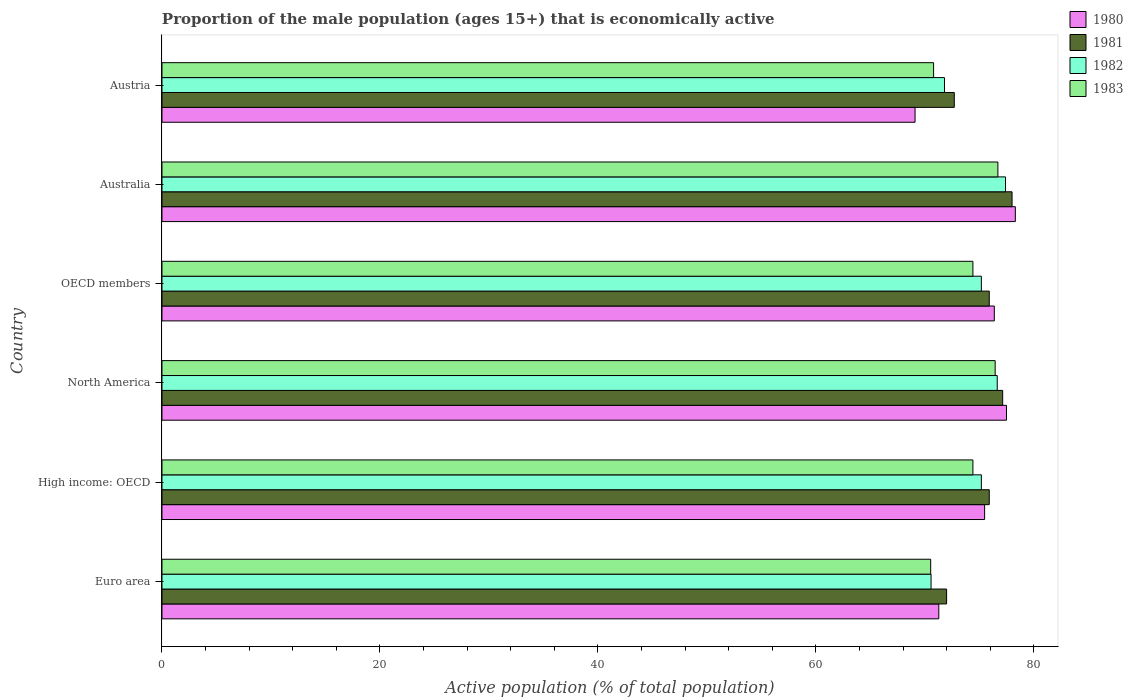How many different coloured bars are there?
Your response must be concise. 4. Are the number of bars per tick equal to the number of legend labels?
Your answer should be compact. Yes. How many bars are there on the 3rd tick from the top?
Your response must be concise. 4. What is the label of the 4th group of bars from the top?
Your answer should be compact. North America. What is the proportion of the male population that is economically active in 1980 in OECD members?
Offer a terse response. 76.37. Across all countries, what is the maximum proportion of the male population that is economically active in 1980?
Your answer should be compact. 78.3. Across all countries, what is the minimum proportion of the male population that is economically active in 1981?
Offer a terse response. 71.99. In which country was the proportion of the male population that is economically active in 1981 maximum?
Your answer should be very brief. Australia. What is the total proportion of the male population that is economically active in 1980 in the graph?
Your answer should be very brief. 448.02. What is the difference between the proportion of the male population that is economically active in 1980 in Australia and that in OECD members?
Provide a short and direct response. 1.93. What is the difference between the proportion of the male population that is economically active in 1981 in Euro area and the proportion of the male population that is economically active in 1980 in High income: OECD?
Your response must be concise. -3.49. What is the average proportion of the male population that is economically active in 1981 per country?
Give a very brief answer. 75.28. What is the difference between the proportion of the male population that is economically active in 1981 and proportion of the male population that is economically active in 1982 in OECD members?
Keep it short and to the point. 0.73. What is the ratio of the proportion of the male population that is economically active in 1982 in Austria to that in OECD members?
Your response must be concise. 0.96. What is the difference between the highest and the second highest proportion of the male population that is economically active in 1980?
Ensure brevity in your answer.  0.81. What is the difference between the highest and the lowest proportion of the male population that is economically active in 1981?
Your response must be concise. 6.01. Is the sum of the proportion of the male population that is economically active in 1983 in Euro area and North America greater than the maximum proportion of the male population that is economically active in 1982 across all countries?
Make the answer very short. Yes. Is it the case that in every country, the sum of the proportion of the male population that is economically active in 1982 and proportion of the male population that is economically active in 1981 is greater than the sum of proportion of the male population that is economically active in 1983 and proportion of the male population that is economically active in 1980?
Give a very brief answer. No. What does the 1st bar from the top in OECD members represents?
Your answer should be compact. 1983. Is it the case that in every country, the sum of the proportion of the male population that is economically active in 1980 and proportion of the male population that is economically active in 1982 is greater than the proportion of the male population that is economically active in 1981?
Provide a short and direct response. Yes. How many bars are there?
Provide a short and direct response. 24. What is the difference between two consecutive major ticks on the X-axis?
Provide a short and direct response. 20. Are the values on the major ticks of X-axis written in scientific E-notation?
Ensure brevity in your answer.  No. Where does the legend appear in the graph?
Your response must be concise. Top right. How many legend labels are there?
Offer a terse response. 4. What is the title of the graph?
Keep it short and to the point. Proportion of the male population (ages 15+) that is economically active. Does "1992" appear as one of the legend labels in the graph?
Provide a succinct answer. No. What is the label or title of the X-axis?
Your answer should be very brief. Active population (% of total population). What is the label or title of the Y-axis?
Your answer should be compact. Country. What is the Active population (% of total population) of 1980 in Euro area?
Make the answer very short. 71.28. What is the Active population (% of total population) in 1981 in Euro area?
Provide a succinct answer. 71.99. What is the Active population (% of total population) in 1982 in Euro area?
Offer a very short reply. 70.57. What is the Active population (% of total population) of 1983 in Euro area?
Give a very brief answer. 70.53. What is the Active population (% of total population) in 1980 in High income: OECD?
Provide a succinct answer. 75.48. What is the Active population (% of total population) in 1981 in High income: OECD?
Your response must be concise. 75.91. What is the Active population (% of total population) in 1982 in High income: OECD?
Make the answer very short. 75.18. What is the Active population (% of total population) of 1983 in High income: OECD?
Your answer should be compact. 74.41. What is the Active population (% of total population) of 1980 in North America?
Offer a terse response. 77.49. What is the Active population (% of total population) in 1981 in North America?
Offer a very short reply. 77.14. What is the Active population (% of total population) of 1982 in North America?
Your response must be concise. 76.64. What is the Active population (% of total population) in 1983 in North America?
Your answer should be very brief. 76.45. What is the Active population (% of total population) in 1980 in OECD members?
Make the answer very short. 76.37. What is the Active population (% of total population) of 1981 in OECD members?
Keep it short and to the point. 75.91. What is the Active population (% of total population) in 1982 in OECD members?
Your answer should be very brief. 75.18. What is the Active population (% of total population) of 1983 in OECD members?
Make the answer very short. 74.41. What is the Active population (% of total population) in 1980 in Australia?
Provide a short and direct response. 78.3. What is the Active population (% of total population) in 1981 in Australia?
Offer a terse response. 78. What is the Active population (% of total population) of 1982 in Australia?
Provide a succinct answer. 77.4. What is the Active population (% of total population) in 1983 in Australia?
Offer a terse response. 76.7. What is the Active population (% of total population) in 1980 in Austria?
Provide a succinct answer. 69.1. What is the Active population (% of total population) of 1981 in Austria?
Your response must be concise. 72.7. What is the Active population (% of total population) of 1982 in Austria?
Offer a terse response. 71.8. What is the Active population (% of total population) of 1983 in Austria?
Ensure brevity in your answer.  70.8. Across all countries, what is the maximum Active population (% of total population) of 1980?
Offer a terse response. 78.3. Across all countries, what is the maximum Active population (% of total population) in 1981?
Provide a short and direct response. 78. Across all countries, what is the maximum Active population (% of total population) in 1982?
Keep it short and to the point. 77.4. Across all countries, what is the maximum Active population (% of total population) of 1983?
Offer a very short reply. 76.7. Across all countries, what is the minimum Active population (% of total population) in 1980?
Keep it short and to the point. 69.1. Across all countries, what is the minimum Active population (% of total population) of 1981?
Your answer should be very brief. 71.99. Across all countries, what is the minimum Active population (% of total population) in 1982?
Provide a succinct answer. 70.57. Across all countries, what is the minimum Active population (% of total population) of 1983?
Provide a short and direct response. 70.53. What is the total Active population (% of total population) of 1980 in the graph?
Your answer should be compact. 448.02. What is the total Active population (% of total population) in 1981 in the graph?
Keep it short and to the point. 451.65. What is the total Active population (% of total population) of 1982 in the graph?
Provide a short and direct response. 446.77. What is the total Active population (% of total population) of 1983 in the graph?
Offer a very short reply. 443.3. What is the difference between the Active population (% of total population) in 1980 in Euro area and that in High income: OECD?
Your response must be concise. -4.2. What is the difference between the Active population (% of total population) of 1981 in Euro area and that in High income: OECD?
Ensure brevity in your answer.  -3.92. What is the difference between the Active population (% of total population) in 1982 in Euro area and that in High income: OECD?
Provide a short and direct response. -4.61. What is the difference between the Active population (% of total population) of 1983 in Euro area and that in High income: OECD?
Provide a succinct answer. -3.87. What is the difference between the Active population (% of total population) in 1980 in Euro area and that in North America?
Ensure brevity in your answer.  -6.21. What is the difference between the Active population (% of total population) of 1981 in Euro area and that in North America?
Give a very brief answer. -5.15. What is the difference between the Active population (% of total population) in 1982 in Euro area and that in North America?
Provide a short and direct response. -6.07. What is the difference between the Active population (% of total population) in 1983 in Euro area and that in North America?
Provide a succinct answer. -5.92. What is the difference between the Active population (% of total population) in 1980 in Euro area and that in OECD members?
Your answer should be very brief. -5.09. What is the difference between the Active population (% of total population) in 1981 in Euro area and that in OECD members?
Your answer should be very brief. -3.92. What is the difference between the Active population (% of total population) of 1982 in Euro area and that in OECD members?
Your response must be concise. -4.61. What is the difference between the Active population (% of total population) in 1983 in Euro area and that in OECD members?
Provide a short and direct response. -3.87. What is the difference between the Active population (% of total population) in 1980 in Euro area and that in Australia?
Provide a short and direct response. -7.02. What is the difference between the Active population (% of total population) in 1981 in Euro area and that in Australia?
Your answer should be compact. -6.01. What is the difference between the Active population (% of total population) of 1982 in Euro area and that in Australia?
Offer a very short reply. -6.83. What is the difference between the Active population (% of total population) in 1983 in Euro area and that in Australia?
Your answer should be compact. -6.17. What is the difference between the Active population (% of total population) in 1980 in Euro area and that in Austria?
Offer a terse response. 2.18. What is the difference between the Active population (% of total population) in 1981 in Euro area and that in Austria?
Offer a terse response. -0.71. What is the difference between the Active population (% of total population) of 1982 in Euro area and that in Austria?
Your answer should be very brief. -1.23. What is the difference between the Active population (% of total population) in 1983 in Euro area and that in Austria?
Provide a succinct answer. -0.27. What is the difference between the Active population (% of total population) of 1980 in High income: OECD and that in North America?
Give a very brief answer. -2.01. What is the difference between the Active population (% of total population) in 1981 in High income: OECD and that in North America?
Offer a very short reply. -1.23. What is the difference between the Active population (% of total population) of 1982 in High income: OECD and that in North America?
Offer a terse response. -1.46. What is the difference between the Active population (% of total population) in 1983 in High income: OECD and that in North America?
Keep it short and to the point. -2.04. What is the difference between the Active population (% of total population) in 1980 in High income: OECD and that in OECD members?
Offer a very short reply. -0.89. What is the difference between the Active population (% of total population) of 1980 in High income: OECD and that in Australia?
Provide a succinct answer. -2.82. What is the difference between the Active population (% of total population) in 1981 in High income: OECD and that in Australia?
Offer a very short reply. -2.09. What is the difference between the Active population (% of total population) in 1982 in High income: OECD and that in Australia?
Your response must be concise. -2.22. What is the difference between the Active population (% of total population) of 1983 in High income: OECD and that in Australia?
Your answer should be compact. -2.29. What is the difference between the Active population (% of total population) of 1980 in High income: OECD and that in Austria?
Provide a succinct answer. 6.38. What is the difference between the Active population (% of total population) in 1981 in High income: OECD and that in Austria?
Your answer should be compact. 3.21. What is the difference between the Active population (% of total population) in 1982 in High income: OECD and that in Austria?
Your response must be concise. 3.38. What is the difference between the Active population (% of total population) in 1983 in High income: OECD and that in Austria?
Ensure brevity in your answer.  3.61. What is the difference between the Active population (% of total population) of 1980 in North America and that in OECD members?
Your response must be concise. 1.12. What is the difference between the Active population (% of total population) in 1981 in North America and that in OECD members?
Provide a short and direct response. 1.23. What is the difference between the Active population (% of total population) of 1982 in North America and that in OECD members?
Ensure brevity in your answer.  1.46. What is the difference between the Active population (% of total population) in 1983 in North America and that in OECD members?
Your answer should be very brief. 2.04. What is the difference between the Active population (% of total population) of 1980 in North America and that in Australia?
Offer a terse response. -0.81. What is the difference between the Active population (% of total population) in 1981 in North America and that in Australia?
Your answer should be compact. -0.86. What is the difference between the Active population (% of total population) of 1982 in North America and that in Australia?
Keep it short and to the point. -0.76. What is the difference between the Active population (% of total population) in 1983 in North America and that in Australia?
Your answer should be very brief. -0.25. What is the difference between the Active population (% of total population) in 1980 in North America and that in Austria?
Give a very brief answer. 8.39. What is the difference between the Active population (% of total population) of 1981 in North America and that in Austria?
Your answer should be very brief. 4.44. What is the difference between the Active population (% of total population) of 1982 in North America and that in Austria?
Ensure brevity in your answer.  4.84. What is the difference between the Active population (% of total population) in 1983 in North America and that in Austria?
Provide a succinct answer. 5.65. What is the difference between the Active population (% of total population) of 1980 in OECD members and that in Australia?
Make the answer very short. -1.93. What is the difference between the Active population (% of total population) of 1981 in OECD members and that in Australia?
Your answer should be compact. -2.09. What is the difference between the Active population (% of total population) of 1982 in OECD members and that in Australia?
Ensure brevity in your answer.  -2.22. What is the difference between the Active population (% of total population) of 1983 in OECD members and that in Australia?
Offer a very short reply. -2.29. What is the difference between the Active population (% of total population) of 1980 in OECD members and that in Austria?
Your answer should be compact. 7.27. What is the difference between the Active population (% of total population) of 1981 in OECD members and that in Austria?
Your answer should be compact. 3.21. What is the difference between the Active population (% of total population) in 1982 in OECD members and that in Austria?
Your answer should be very brief. 3.38. What is the difference between the Active population (% of total population) of 1983 in OECD members and that in Austria?
Your answer should be compact. 3.61. What is the difference between the Active population (% of total population) of 1980 in Australia and that in Austria?
Offer a very short reply. 9.2. What is the difference between the Active population (% of total population) in 1981 in Australia and that in Austria?
Your answer should be very brief. 5.3. What is the difference between the Active population (% of total population) of 1982 in Australia and that in Austria?
Offer a very short reply. 5.6. What is the difference between the Active population (% of total population) of 1983 in Australia and that in Austria?
Provide a succinct answer. 5.9. What is the difference between the Active population (% of total population) of 1980 in Euro area and the Active population (% of total population) of 1981 in High income: OECD?
Provide a short and direct response. -4.63. What is the difference between the Active population (% of total population) of 1980 in Euro area and the Active population (% of total population) of 1982 in High income: OECD?
Your answer should be very brief. -3.9. What is the difference between the Active population (% of total population) of 1980 in Euro area and the Active population (% of total population) of 1983 in High income: OECD?
Offer a terse response. -3.13. What is the difference between the Active population (% of total population) in 1981 in Euro area and the Active population (% of total population) in 1982 in High income: OECD?
Provide a succinct answer. -3.19. What is the difference between the Active population (% of total population) in 1981 in Euro area and the Active population (% of total population) in 1983 in High income: OECD?
Provide a succinct answer. -2.41. What is the difference between the Active population (% of total population) in 1982 in Euro area and the Active population (% of total population) in 1983 in High income: OECD?
Your answer should be very brief. -3.84. What is the difference between the Active population (% of total population) of 1980 in Euro area and the Active population (% of total population) of 1981 in North America?
Your answer should be compact. -5.86. What is the difference between the Active population (% of total population) in 1980 in Euro area and the Active population (% of total population) in 1982 in North America?
Provide a short and direct response. -5.36. What is the difference between the Active population (% of total population) in 1980 in Euro area and the Active population (% of total population) in 1983 in North America?
Make the answer very short. -5.17. What is the difference between the Active population (% of total population) in 1981 in Euro area and the Active population (% of total population) in 1982 in North America?
Make the answer very short. -4.65. What is the difference between the Active population (% of total population) in 1981 in Euro area and the Active population (% of total population) in 1983 in North America?
Make the answer very short. -4.46. What is the difference between the Active population (% of total population) in 1982 in Euro area and the Active population (% of total population) in 1983 in North America?
Your answer should be very brief. -5.88. What is the difference between the Active population (% of total population) in 1980 in Euro area and the Active population (% of total population) in 1981 in OECD members?
Make the answer very short. -4.63. What is the difference between the Active population (% of total population) of 1980 in Euro area and the Active population (% of total population) of 1982 in OECD members?
Make the answer very short. -3.9. What is the difference between the Active population (% of total population) of 1980 in Euro area and the Active population (% of total population) of 1983 in OECD members?
Offer a terse response. -3.13. What is the difference between the Active population (% of total population) in 1981 in Euro area and the Active population (% of total population) in 1982 in OECD members?
Your answer should be compact. -3.19. What is the difference between the Active population (% of total population) in 1981 in Euro area and the Active population (% of total population) in 1983 in OECD members?
Offer a terse response. -2.41. What is the difference between the Active population (% of total population) in 1982 in Euro area and the Active population (% of total population) in 1983 in OECD members?
Give a very brief answer. -3.84. What is the difference between the Active population (% of total population) of 1980 in Euro area and the Active population (% of total population) of 1981 in Australia?
Keep it short and to the point. -6.72. What is the difference between the Active population (% of total population) of 1980 in Euro area and the Active population (% of total population) of 1982 in Australia?
Provide a short and direct response. -6.12. What is the difference between the Active population (% of total population) of 1980 in Euro area and the Active population (% of total population) of 1983 in Australia?
Make the answer very short. -5.42. What is the difference between the Active population (% of total population) of 1981 in Euro area and the Active population (% of total population) of 1982 in Australia?
Provide a succinct answer. -5.41. What is the difference between the Active population (% of total population) in 1981 in Euro area and the Active population (% of total population) in 1983 in Australia?
Your response must be concise. -4.71. What is the difference between the Active population (% of total population) in 1982 in Euro area and the Active population (% of total population) in 1983 in Australia?
Provide a succinct answer. -6.13. What is the difference between the Active population (% of total population) in 1980 in Euro area and the Active population (% of total population) in 1981 in Austria?
Ensure brevity in your answer.  -1.42. What is the difference between the Active population (% of total population) in 1980 in Euro area and the Active population (% of total population) in 1982 in Austria?
Provide a succinct answer. -0.52. What is the difference between the Active population (% of total population) of 1980 in Euro area and the Active population (% of total population) of 1983 in Austria?
Provide a succinct answer. 0.48. What is the difference between the Active population (% of total population) of 1981 in Euro area and the Active population (% of total population) of 1982 in Austria?
Keep it short and to the point. 0.19. What is the difference between the Active population (% of total population) in 1981 in Euro area and the Active population (% of total population) in 1983 in Austria?
Your answer should be compact. 1.19. What is the difference between the Active population (% of total population) of 1982 in Euro area and the Active population (% of total population) of 1983 in Austria?
Offer a very short reply. -0.23. What is the difference between the Active population (% of total population) in 1980 in High income: OECD and the Active population (% of total population) in 1981 in North America?
Keep it short and to the point. -1.66. What is the difference between the Active population (% of total population) in 1980 in High income: OECD and the Active population (% of total population) in 1982 in North America?
Keep it short and to the point. -1.16. What is the difference between the Active population (% of total population) of 1980 in High income: OECD and the Active population (% of total population) of 1983 in North America?
Give a very brief answer. -0.97. What is the difference between the Active population (% of total population) of 1981 in High income: OECD and the Active population (% of total population) of 1982 in North America?
Offer a terse response. -0.73. What is the difference between the Active population (% of total population) of 1981 in High income: OECD and the Active population (% of total population) of 1983 in North America?
Provide a succinct answer. -0.54. What is the difference between the Active population (% of total population) of 1982 in High income: OECD and the Active population (% of total population) of 1983 in North America?
Offer a very short reply. -1.27. What is the difference between the Active population (% of total population) in 1980 in High income: OECD and the Active population (% of total population) in 1981 in OECD members?
Keep it short and to the point. -0.43. What is the difference between the Active population (% of total population) of 1980 in High income: OECD and the Active population (% of total population) of 1982 in OECD members?
Your answer should be very brief. 0.3. What is the difference between the Active population (% of total population) in 1980 in High income: OECD and the Active population (% of total population) in 1983 in OECD members?
Your answer should be compact. 1.07. What is the difference between the Active population (% of total population) of 1981 in High income: OECD and the Active population (% of total population) of 1982 in OECD members?
Provide a succinct answer. 0.73. What is the difference between the Active population (% of total population) of 1981 in High income: OECD and the Active population (% of total population) of 1983 in OECD members?
Offer a terse response. 1.5. What is the difference between the Active population (% of total population) in 1982 in High income: OECD and the Active population (% of total population) in 1983 in OECD members?
Your answer should be very brief. 0.77. What is the difference between the Active population (% of total population) in 1980 in High income: OECD and the Active population (% of total population) in 1981 in Australia?
Your answer should be very brief. -2.52. What is the difference between the Active population (% of total population) in 1980 in High income: OECD and the Active population (% of total population) in 1982 in Australia?
Offer a terse response. -1.92. What is the difference between the Active population (% of total population) in 1980 in High income: OECD and the Active population (% of total population) in 1983 in Australia?
Provide a succinct answer. -1.22. What is the difference between the Active population (% of total population) in 1981 in High income: OECD and the Active population (% of total population) in 1982 in Australia?
Make the answer very short. -1.49. What is the difference between the Active population (% of total population) of 1981 in High income: OECD and the Active population (% of total population) of 1983 in Australia?
Give a very brief answer. -0.79. What is the difference between the Active population (% of total population) in 1982 in High income: OECD and the Active population (% of total population) in 1983 in Australia?
Offer a very short reply. -1.52. What is the difference between the Active population (% of total population) in 1980 in High income: OECD and the Active population (% of total population) in 1981 in Austria?
Offer a terse response. 2.78. What is the difference between the Active population (% of total population) of 1980 in High income: OECD and the Active population (% of total population) of 1982 in Austria?
Offer a very short reply. 3.68. What is the difference between the Active population (% of total population) in 1980 in High income: OECD and the Active population (% of total population) in 1983 in Austria?
Ensure brevity in your answer.  4.68. What is the difference between the Active population (% of total population) in 1981 in High income: OECD and the Active population (% of total population) in 1982 in Austria?
Keep it short and to the point. 4.11. What is the difference between the Active population (% of total population) in 1981 in High income: OECD and the Active population (% of total population) in 1983 in Austria?
Give a very brief answer. 5.11. What is the difference between the Active population (% of total population) in 1982 in High income: OECD and the Active population (% of total population) in 1983 in Austria?
Offer a terse response. 4.38. What is the difference between the Active population (% of total population) of 1980 in North America and the Active population (% of total population) of 1981 in OECD members?
Provide a short and direct response. 1.58. What is the difference between the Active population (% of total population) of 1980 in North America and the Active population (% of total population) of 1982 in OECD members?
Your answer should be very brief. 2.31. What is the difference between the Active population (% of total population) in 1980 in North America and the Active population (% of total population) in 1983 in OECD members?
Provide a succinct answer. 3.08. What is the difference between the Active population (% of total population) of 1981 in North America and the Active population (% of total population) of 1982 in OECD members?
Your answer should be very brief. 1.96. What is the difference between the Active population (% of total population) in 1981 in North America and the Active population (% of total population) in 1983 in OECD members?
Your answer should be compact. 2.73. What is the difference between the Active population (% of total population) of 1982 in North America and the Active population (% of total population) of 1983 in OECD members?
Provide a short and direct response. 2.23. What is the difference between the Active population (% of total population) of 1980 in North America and the Active population (% of total population) of 1981 in Australia?
Offer a very short reply. -0.51. What is the difference between the Active population (% of total population) of 1980 in North America and the Active population (% of total population) of 1982 in Australia?
Offer a terse response. 0.09. What is the difference between the Active population (% of total population) in 1980 in North America and the Active population (% of total population) in 1983 in Australia?
Keep it short and to the point. 0.79. What is the difference between the Active population (% of total population) of 1981 in North America and the Active population (% of total population) of 1982 in Australia?
Make the answer very short. -0.26. What is the difference between the Active population (% of total population) of 1981 in North America and the Active population (% of total population) of 1983 in Australia?
Your answer should be very brief. 0.44. What is the difference between the Active population (% of total population) in 1982 in North America and the Active population (% of total population) in 1983 in Australia?
Make the answer very short. -0.06. What is the difference between the Active population (% of total population) of 1980 in North America and the Active population (% of total population) of 1981 in Austria?
Provide a succinct answer. 4.79. What is the difference between the Active population (% of total population) of 1980 in North America and the Active population (% of total population) of 1982 in Austria?
Your answer should be compact. 5.69. What is the difference between the Active population (% of total population) in 1980 in North America and the Active population (% of total population) in 1983 in Austria?
Provide a short and direct response. 6.69. What is the difference between the Active population (% of total population) in 1981 in North America and the Active population (% of total population) in 1982 in Austria?
Your response must be concise. 5.34. What is the difference between the Active population (% of total population) of 1981 in North America and the Active population (% of total population) of 1983 in Austria?
Keep it short and to the point. 6.34. What is the difference between the Active population (% of total population) of 1982 in North America and the Active population (% of total population) of 1983 in Austria?
Provide a succinct answer. 5.84. What is the difference between the Active population (% of total population) of 1980 in OECD members and the Active population (% of total population) of 1981 in Australia?
Provide a short and direct response. -1.63. What is the difference between the Active population (% of total population) in 1980 in OECD members and the Active population (% of total population) in 1982 in Australia?
Your response must be concise. -1.03. What is the difference between the Active population (% of total population) of 1980 in OECD members and the Active population (% of total population) of 1983 in Australia?
Ensure brevity in your answer.  -0.33. What is the difference between the Active population (% of total population) in 1981 in OECD members and the Active population (% of total population) in 1982 in Australia?
Keep it short and to the point. -1.49. What is the difference between the Active population (% of total population) in 1981 in OECD members and the Active population (% of total population) in 1983 in Australia?
Provide a short and direct response. -0.79. What is the difference between the Active population (% of total population) in 1982 in OECD members and the Active population (% of total population) in 1983 in Australia?
Ensure brevity in your answer.  -1.52. What is the difference between the Active population (% of total population) in 1980 in OECD members and the Active population (% of total population) in 1981 in Austria?
Provide a short and direct response. 3.67. What is the difference between the Active population (% of total population) of 1980 in OECD members and the Active population (% of total population) of 1982 in Austria?
Offer a terse response. 4.57. What is the difference between the Active population (% of total population) in 1980 in OECD members and the Active population (% of total population) in 1983 in Austria?
Your answer should be compact. 5.57. What is the difference between the Active population (% of total population) in 1981 in OECD members and the Active population (% of total population) in 1982 in Austria?
Keep it short and to the point. 4.11. What is the difference between the Active population (% of total population) in 1981 in OECD members and the Active population (% of total population) in 1983 in Austria?
Make the answer very short. 5.11. What is the difference between the Active population (% of total population) of 1982 in OECD members and the Active population (% of total population) of 1983 in Austria?
Give a very brief answer. 4.38. What is the difference between the Active population (% of total population) in 1980 in Australia and the Active population (% of total population) in 1982 in Austria?
Ensure brevity in your answer.  6.5. What is the difference between the Active population (% of total population) of 1980 in Australia and the Active population (% of total population) of 1983 in Austria?
Provide a succinct answer. 7.5. What is the difference between the Active population (% of total population) in 1981 in Australia and the Active population (% of total population) in 1982 in Austria?
Provide a short and direct response. 6.2. What is the difference between the Active population (% of total population) in 1981 in Australia and the Active population (% of total population) in 1983 in Austria?
Your response must be concise. 7.2. What is the average Active population (% of total population) of 1980 per country?
Ensure brevity in your answer.  74.67. What is the average Active population (% of total population) of 1981 per country?
Provide a succinct answer. 75.28. What is the average Active population (% of total population) of 1982 per country?
Give a very brief answer. 74.46. What is the average Active population (% of total population) of 1983 per country?
Your answer should be very brief. 73.88. What is the difference between the Active population (% of total population) of 1980 and Active population (% of total population) of 1981 in Euro area?
Keep it short and to the point. -0.72. What is the difference between the Active population (% of total population) of 1980 and Active population (% of total population) of 1982 in Euro area?
Keep it short and to the point. 0.71. What is the difference between the Active population (% of total population) in 1980 and Active population (% of total population) in 1983 in Euro area?
Make the answer very short. 0.74. What is the difference between the Active population (% of total population) of 1981 and Active population (% of total population) of 1982 in Euro area?
Provide a short and direct response. 1.43. What is the difference between the Active population (% of total population) of 1981 and Active population (% of total population) of 1983 in Euro area?
Keep it short and to the point. 1.46. What is the difference between the Active population (% of total population) in 1982 and Active population (% of total population) in 1983 in Euro area?
Offer a very short reply. 0.03. What is the difference between the Active population (% of total population) in 1980 and Active population (% of total population) in 1981 in High income: OECD?
Give a very brief answer. -0.43. What is the difference between the Active population (% of total population) in 1980 and Active population (% of total population) in 1982 in High income: OECD?
Make the answer very short. 0.3. What is the difference between the Active population (% of total population) of 1980 and Active population (% of total population) of 1983 in High income: OECD?
Offer a very short reply. 1.07. What is the difference between the Active population (% of total population) of 1981 and Active population (% of total population) of 1982 in High income: OECD?
Offer a terse response. 0.73. What is the difference between the Active population (% of total population) in 1981 and Active population (% of total population) in 1983 in High income: OECD?
Give a very brief answer. 1.5. What is the difference between the Active population (% of total population) of 1982 and Active population (% of total population) of 1983 in High income: OECD?
Give a very brief answer. 0.77. What is the difference between the Active population (% of total population) of 1980 and Active population (% of total population) of 1981 in North America?
Offer a very short reply. 0.35. What is the difference between the Active population (% of total population) of 1980 and Active population (% of total population) of 1982 in North America?
Make the answer very short. 0.85. What is the difference between the Active population (% of total population) in 1980 and Active population (% of total population) in 1983 in North America?
Offer a very short reply. 1.04. What is the difference between the Active population (% of total population) in 1981 and Active population (% of total population) in 1982 in North America?
Offer a very short reply. 0.5. What is the difference between the Active population (% of total population) in 1981 and Active population (% of total population) in 1983 in North America?
Provide a short and direct response. 0.69. What is the difference between the Active population (% of total population) of 1982 and Active population (% of total population) of 1983 in North America?
Your answer should be compact. 0.19. What is the difference between the Active population (% of total population) of 1980 and Active population (% of total population) of 1981 in OECD members?
Your answer should be compact. 0.46. What is the difference between the Active population (% of total population) of 1980 and Active population (% of total population) of 1982 in OECD members?
Keep it short and to the point. 1.19. What is the difference between the Active population (% of total population) in 1980 and Active population (% of total population) in 1983 in OECD members?
Make the answer very short. 1.96. What is the difference between the Active population (% of total population) of 1981 and Active population (% of total population) of 1982 in OECD members?
Ensure brevity in your answer.  0.73. What is the difference between the Active population (% of total population) in 1981 and Active population (% of total population) in 1983 in OECD members?
Give a very brief answer. 1.5. What is the difference between the Active population (% of total population) in 1982 and Active population (% of total population) in 1983 in OECD members?
Your answer should be very brief. 0.77. What is the difference between the Active population (% of total population) in 1980 and Active population (% of total population) in 1981 in Australia?
Your answer should be compact. 0.3. What is the difference between the Active population (% of total population) of 1980 and Active population (% of total population) of 1982 in Australia?
Keep it short and to the point. 0.9. What is the difference between the Active population (% of total population) in 1980 and Active population (% of total population) in 1983 in Australia?
Your answer should be compact. 1.6. What is the difference between the Active population (% of total population) in 1981 and Active population (% of total population) in 1983 in Australia?
Make the answer very short. 1.3. What is the difference between the Active population (% of total population) in 1982 and Active population (% of total population) in 1983 in Australia?
Your response must be concise. 0.7. What is the difference between the Active population (% of total population) in 1980 and Active population (% of total population) in 1983 in Austria?
Ensure brevity in your answer.  -1.7. What is the difference between the Active population (% of total population) in 1982 and Active population (% of total population) in 1983 in Austria?
Your answer should be compact. 1. What is the ratio of the Active population (% of total population) in 1980 in Euro area to that in High income: OECD?
Give a very brief answer. 0.94. What is the ratio of the Active population (% of total population) in 1981 in Euro area to that in High income: OECD?
Ensure brevity in your answer.  0.95. What is the ratio of the Active population (% of total population) of 1982 in Euro area to that in High income: OECD?
Ensure brevity in your answer.  0.94. What is the ratio of the Active population (% of total population) in 1983 in Euro area to that in High income: OECD?
Make the answer very short. 0.95. What is the ratio of the Active population (% of total population) in 1980 in Euro area to that in North America?
Provide a succinct answer. 0.92. What is the ratio of the Active population (% of total population) of 1982 in Euro area to that in North America?
Make the answer very short. 0.92. What is the ratio of the Active population (% of total population) in 1983 in Euro area to that in North America?
Provide a short and direct response. 0.92. What is the ratio of the Active population (% of total population) in 1981 in Euro area to that in OECD members?
Your answer should be very brief. 0.95. What is the ratio of the Active population (% of total population) of 1982 in Euro area to that in OECD members?
Make the answer very short. 0.94. What is the ratio of the Active population (% of total population) in 1983 in Euro area to that in OECD members?
Give a very brief answer. 0.95. What is the ratio of the Active population (% of total population) in 1980 in Euro area to that in Australia?
Offer a terse response. 0.91. What is the ratio of the Active population (% of total population) in 1981 in Euro area to that in Australia?
Give a very brief answer. 0.92. What is the ratio of the Active population (% of total population) of 1982 in Euro area to that in Australia?
Offer a terse response. 0.91. What is the ratio of the Active population (% of total population) in 1983 in Euro area to that in Australia?
Make the answer very short. 0.92. What is the ratio of the Active population (% of total population) in 1980 in Euro area to that in Austria?
Keep it short and to the point. 1.03. What is the ratio of the Active population (% of total population) of 1981 in Euro area to that in Austria?
Make the answer very short. 0.99. What is the ratio of the Active population (% of total population) in 1982 in Euro area to that in Austria?
Your answer should be very brief. 0.98. What is the ratio of the Active population (% of total population) in 1983 in Euro area to that in Austria?
Provide a short and direct response. 1. What is the ratio of the Active population (% of total population) in 1980 in High income: OECD to that in North America?
Provide a succinct answer. 0.97. What is the ratio of the Active population (% of total population) in 1983 in High income: OECD to that in North America?
Keep it short and to the point. 0.97. What is the ratio of the Active population (% of total population) in 1980 in High income: OECD to that in OECD members?
Ensure brevity in your answer.  0.99. What is the ratio of the Active population (% of total population) of 1981 in High income: OECD to that in OECD members?
Your response must be concise. 1. What is the ratio of the Active population (% of total population) of 1983 in High income: OECD to that in OECD members?
Offer a very short reply. 1. What is the ratio of the Active population (% of total population) of 1981 in High income: OECD to that in Australia?
Ensure brevity in your answer.  0.97. What is the ratio of the Active population (% of total population) of 1982 in High income: OECD to that in Australia?
Offer a very short reply. 0.97. What is the ratio of the Active population (% of total population) of 1983 in High income: OECD to that in Australia?
Offer a very short reply. 0.97. What is the ratio of the Active population (% of total population) in 1980 in High income: OECD to that in Austria?
Your response must be concise. 1.09. What is the ratio of the Active population (% of total population) in 1981 in High income: OECD to that in Austria?
Offer a very short reply. 1.04. What is the ratio of the Active population (% of total population) of 1982 in High income: OECD to that in Austria?
Keep it short and to the point. 1.05. What is the ratio of the Active population (% of total population) in 1983 in High income: OECD to that in Austria?
Ensure brevity in your answer.  1.05. What is the ratio of the Active population (% of total population) in 1980 in North America to that in OECD members?
Ensure brevity in your answer.  1.01. What is the ratio of the Active population (% of total population) of 1981 in North America to that in OECD members?
Your response must be concise. 1.02. What is the ratio of the Active population (% of total population) of 1982 in North America to that in OECD members?
Ensure brevity in your answer.  1.02. What is the ratio of the Active population (% of total population) in 1983 in North America to that in OECD members?
Give a very brief answer. 1.03. What is the ratio of the Active population (% of total population) of 1982 in North America to that in Australia?
Keep it short and to the point. 0.99. What is the ratio of the Active population (% of total population) of 1983 in North America to that in Australia?
Provide a succinct answer. 1. What is the ratio of the Active population (% of total population) in 1980 in North America to that in Austria?
Keep it short and to the point. 1.12. What is the ratio of the Active population (% of total population) in 1981 in North America to that in Austria?
Give a very brief answer. 1.06. What is the ratio of the Active population (% of total population) in 1982 in North America to that in Austria?
Offer a terse response. 1.07. What is the ratio of the Active population (% of total population) of 1983 in North America to that in Austria?
Keep it short and to the point. 1.08. What is the ratio of the Active population (% of total population) of 1980 in OECD members to that in Australia?
Offer a terse response. 0.98. What is the ratio of the Active population (% of total population) in 1981 in OECD members to that in Australia?
Your response must be concise. 0.97. What is the ratio of the Active population (% of total population) of 1982 in OECD members to that in Australia?
Make the answer very short. 0.97. What is the ratio of the Active population (% of total population) in 1983 in OECD members to that in Australia?
Your answer should be compact. 0.97. What is the ratio of the Active population (% of total population) in 1980 in OECD members to that in Austria?
Provide a succinct answer. 1.11. What is the ratio of the Active population (% of total population) of 1981 in OECD members to that in Austria?
Provide a short and direct response. 1.04. What is the ratio of the Active population (% of total population) in 1982 in OECD members to that in Austria?
Offer a terse response. 1.05. What is the ratio of the Active population (% of total population) of 1983 in OECD members to that in Austria?
Provide a short and direct response. 1.05. What is the ratio of the Active population (% of total population) of 1980 in Australia to that in Austria?
Your answer should be compact. 1.13. What is the ratio of the Active population (% of total population) in 1981 in Australia to that in Austria?
Make the answer very short. 1.07. What is the ratio of the Active population (% of total population) in 1982 in Australia to that in Austria?
Your answer should be compact. 1.08. What is the ratio of the Active population (% of total population) in 1983 in Australia to that in Austria?
Ensure brevity in your answer.  1.08. What is the difference between the highest and the second highest Active population (% of total population) of 1980?
Offer a very short reply. 0.81. What is the difference between the highest and the second highest Active population (% of total population) of 1981?
Your answer should be very brief. 0.86. What is the difference between the highest and the second highest Active population (% of total population) in 1982?
Provide a short and direct response. 0.76. What is the difference between the highest and the second highest Active population (% of total population) of 1983?
Ensure brevity in your answer.  0.25. What is the difference between the highest and the lowest Active population (% of total population) in 1980?
Make the answer very short. 9.2. What is the difference between the highest and the lowest Active population (% of total population) of 1981?
Ensure brevity in your answer.  6.01. What is the difference between the highest and the lowest Active population (% of total population) of 1982?
Give a very brief answer. 6.83. What is the difference between the highest and the lowest Active population (% of total population) of 1983?
Your response must be concise. 6.17. 